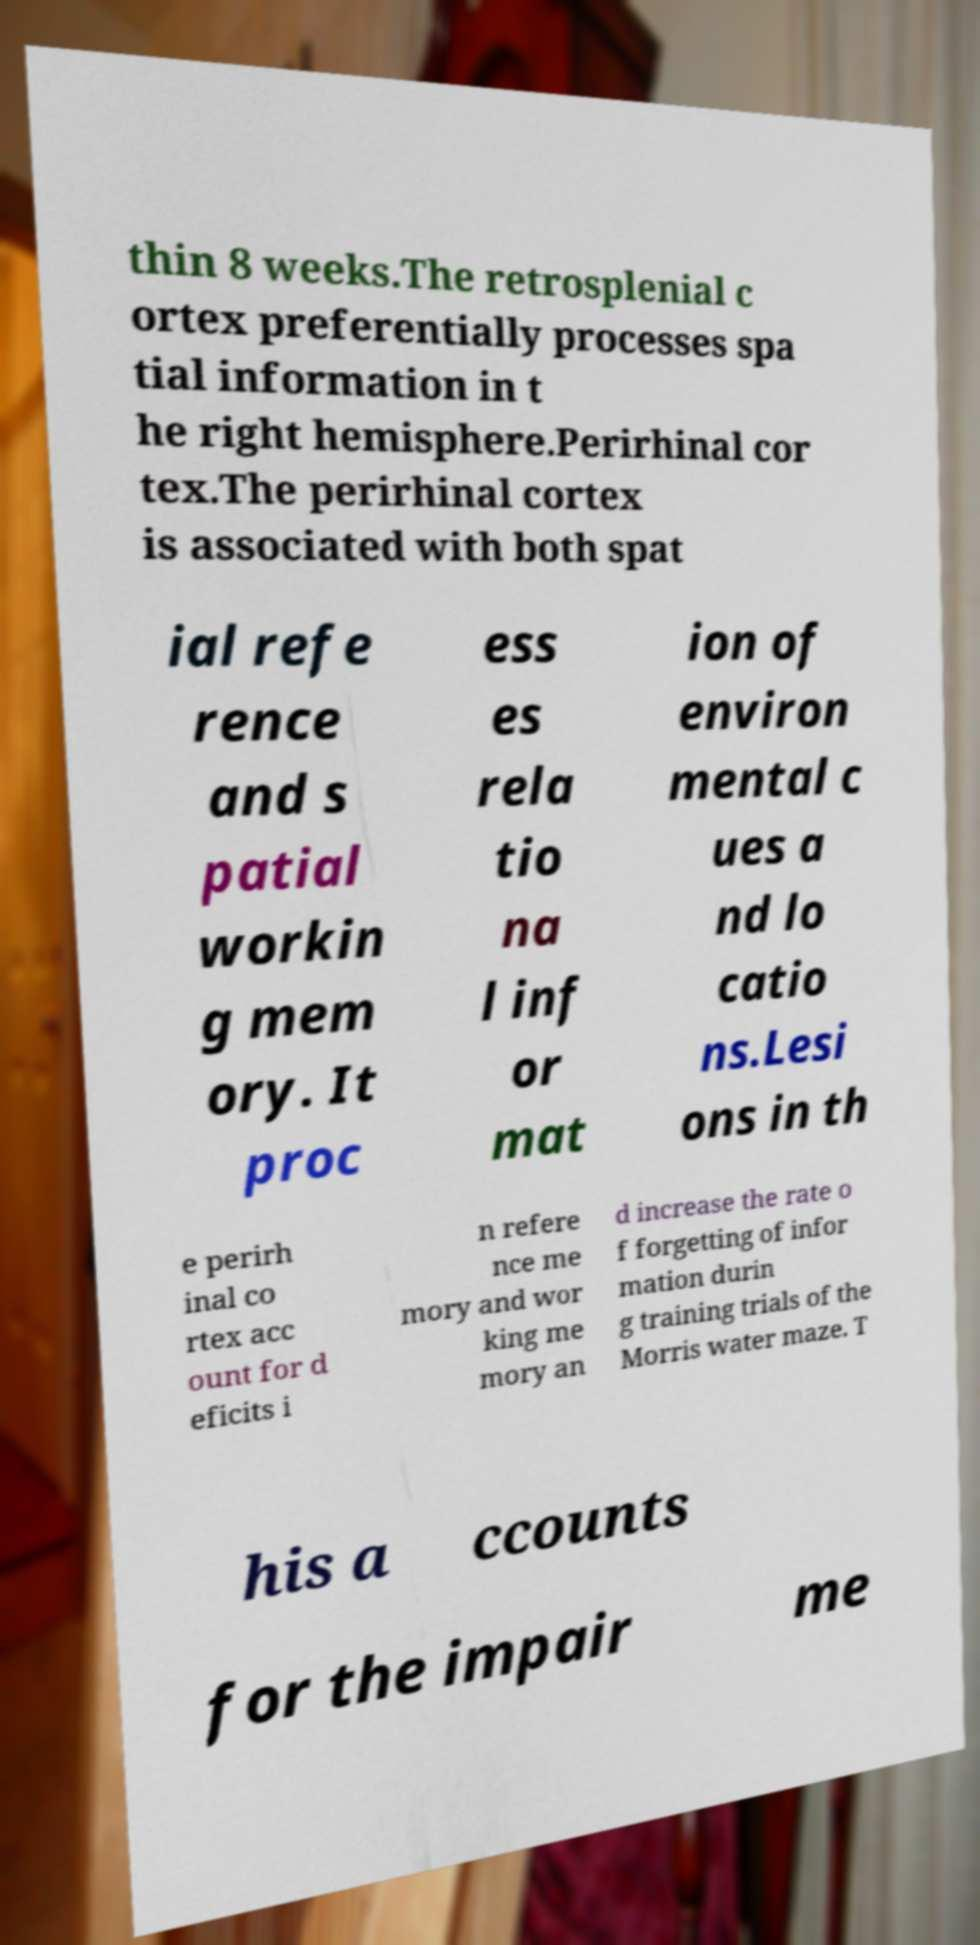Can you accurately transcribe the text from the provided image for me? thin 8 weeks.The retrosplenial c ortex preferentially processes spa tial information in t he right hemisphere.Perirhinal cor tex.The perirhinal cortex is associated with both spat ial refe rence and s patial workin g mem ory. It proc ess es rela tio na l inf or mat ion of environ mental c ues a nd lo catio ns.Lesi ons in th e perirh inal co rtex acc ount for d eficits i n refere nce me mory and wor king me mory an d increase the rate o f forgetting of infor mation durin g training trials of the Morris water maze. T his a ccounts for the impair me 